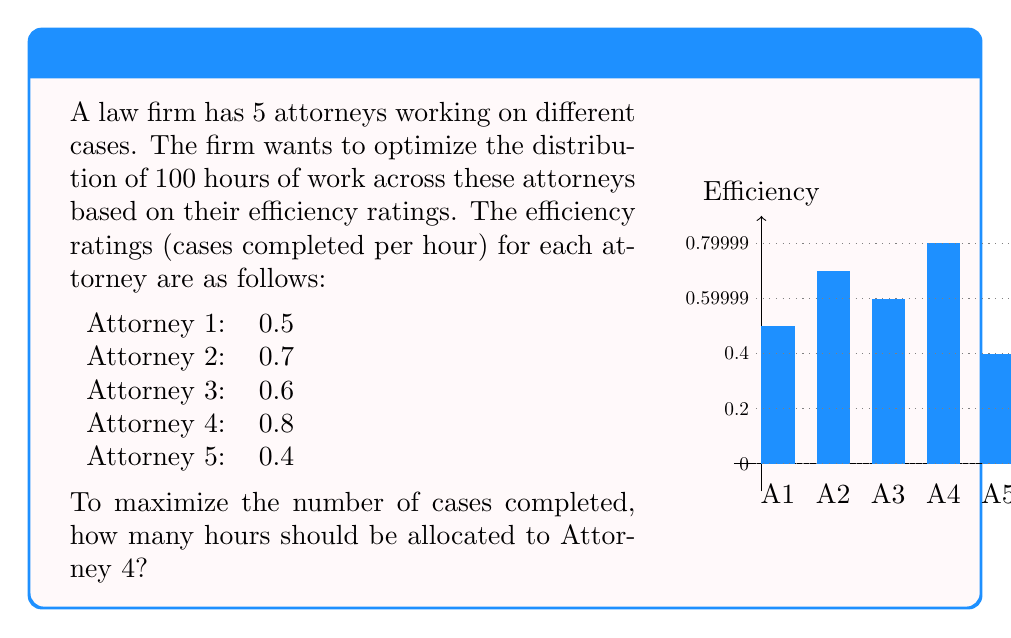What is the answer to this math problem? To optimize resource allocation and maximize the number of cases completed, we should allocate the most hours to the attorney with the highest efficiency rating. Let's approach this step-by-step:

1) First, identify the attorney with the highest efficiency rating:
   Attorney 4 has the highest rating at 0.8 cases per hour.

2) The optimal strategy is to allocate all available hours to the most efficient attorney until their capacity is reached or all hours are used.

3) In this case, we have 100 hours to distribute, and Attorney 4 is the most efficient.

4) Since there are no constraints mentioned on individual attorney workload, we can allocate all 100 hours to Attorney 4.

5) Let's verify the optimality:
   - If Attorney 4 works for 100 hours, they will complete:
     $100 \times 0.8 = 80$ cases

   - This is better than any other allocation. For example, if we split the hours equally:
     $$(0.5 + 0.7 + 0.6 + 0.8 + 0.4) \times 20 = 60$$ cases

6) Therefore, to maximize the number of cases completed, all 100 hours should be allocated to Attorney 4.
Answer: 100 hours 